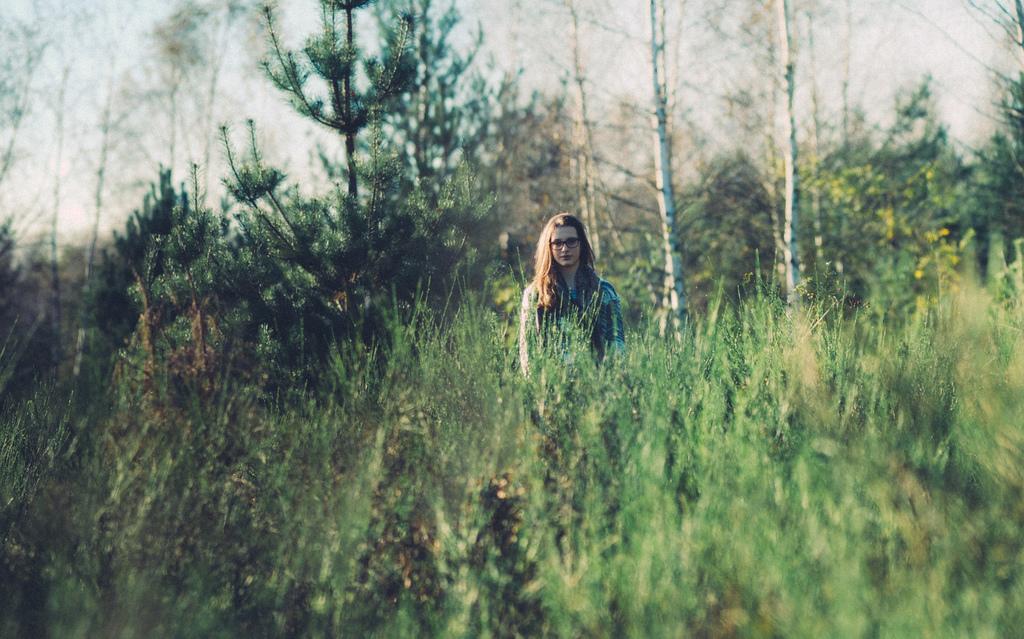In one or two sentences, can you explain what this image depicts? In this image we can see a lady. There are many trees and plants in the image. There is a sky in the image. 